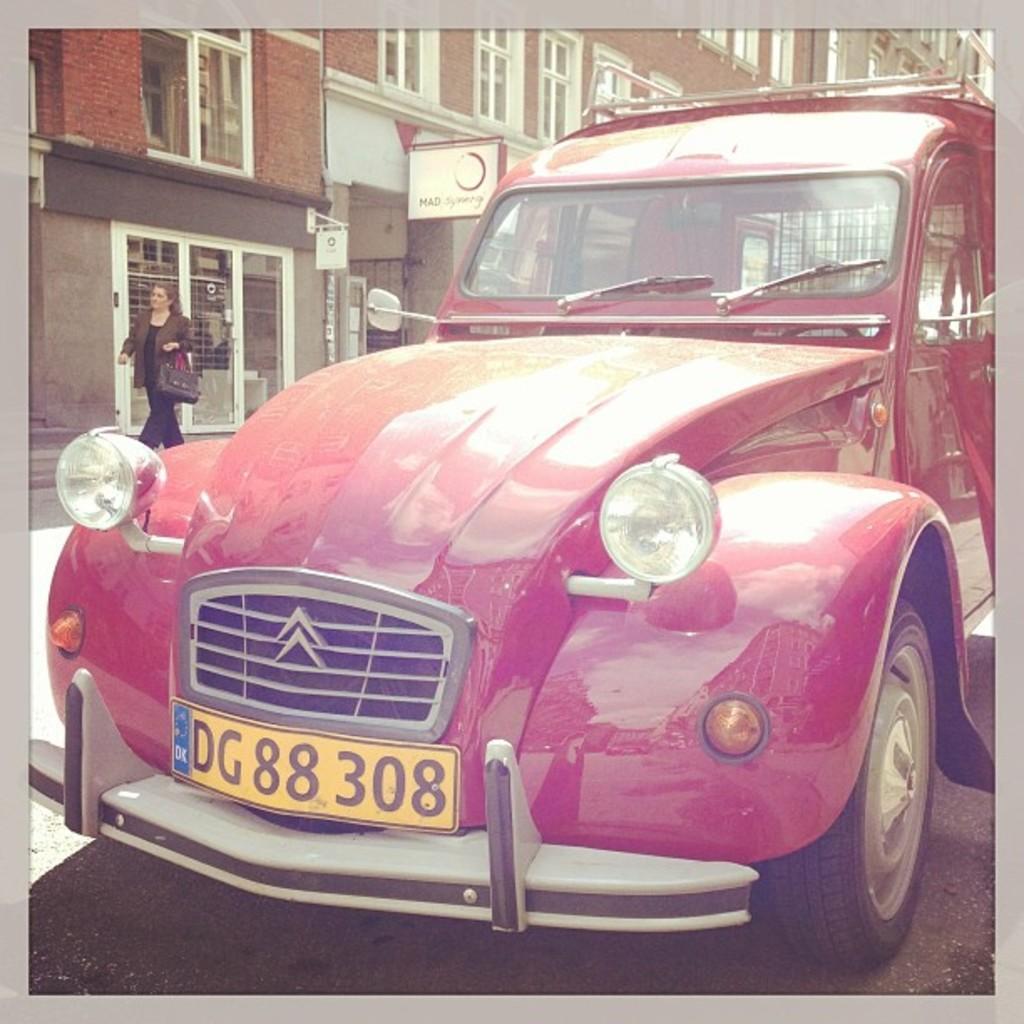Could you give a brief overview of what you see in this image? In this picture we can see a car and a registration plate on a car. There is a board on the pole. We can see another board on the building. A woman wearing handbag is walking on the path. 